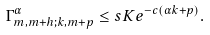<formula> <loc_0><loc_0><loc_500><loc_500>\Gamma ^ { \alpha } _ { m , m + h ; k , m + p } \leq s K e ^ { - c ( \alpha k + p ) } .</formula> 